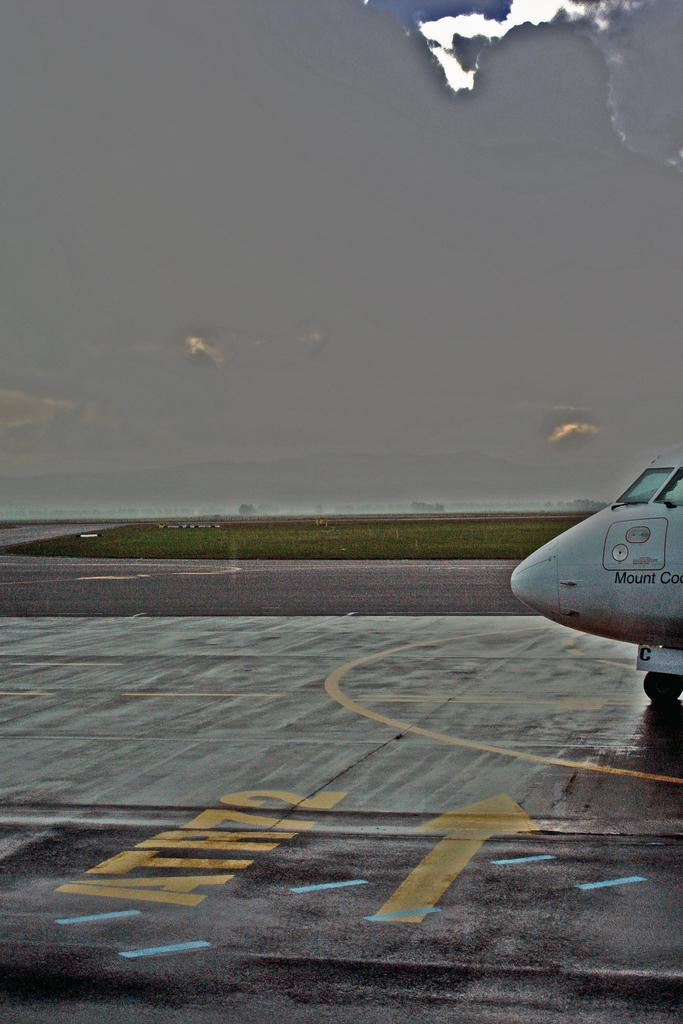What is the unusual object on the road in the image? There is an aircraft on the road in the image. What type of vegetation can be seen in the background? There is grass visible in the background. What is visible in the sky in the image? There are clouds in the sky, and the sky is visible in the background. What type of question can be seen in the image? There is no question visible in the image; it is a photograph of an aircraft on the road. Can you spot a snake in the image? There is no snake present in the image. 